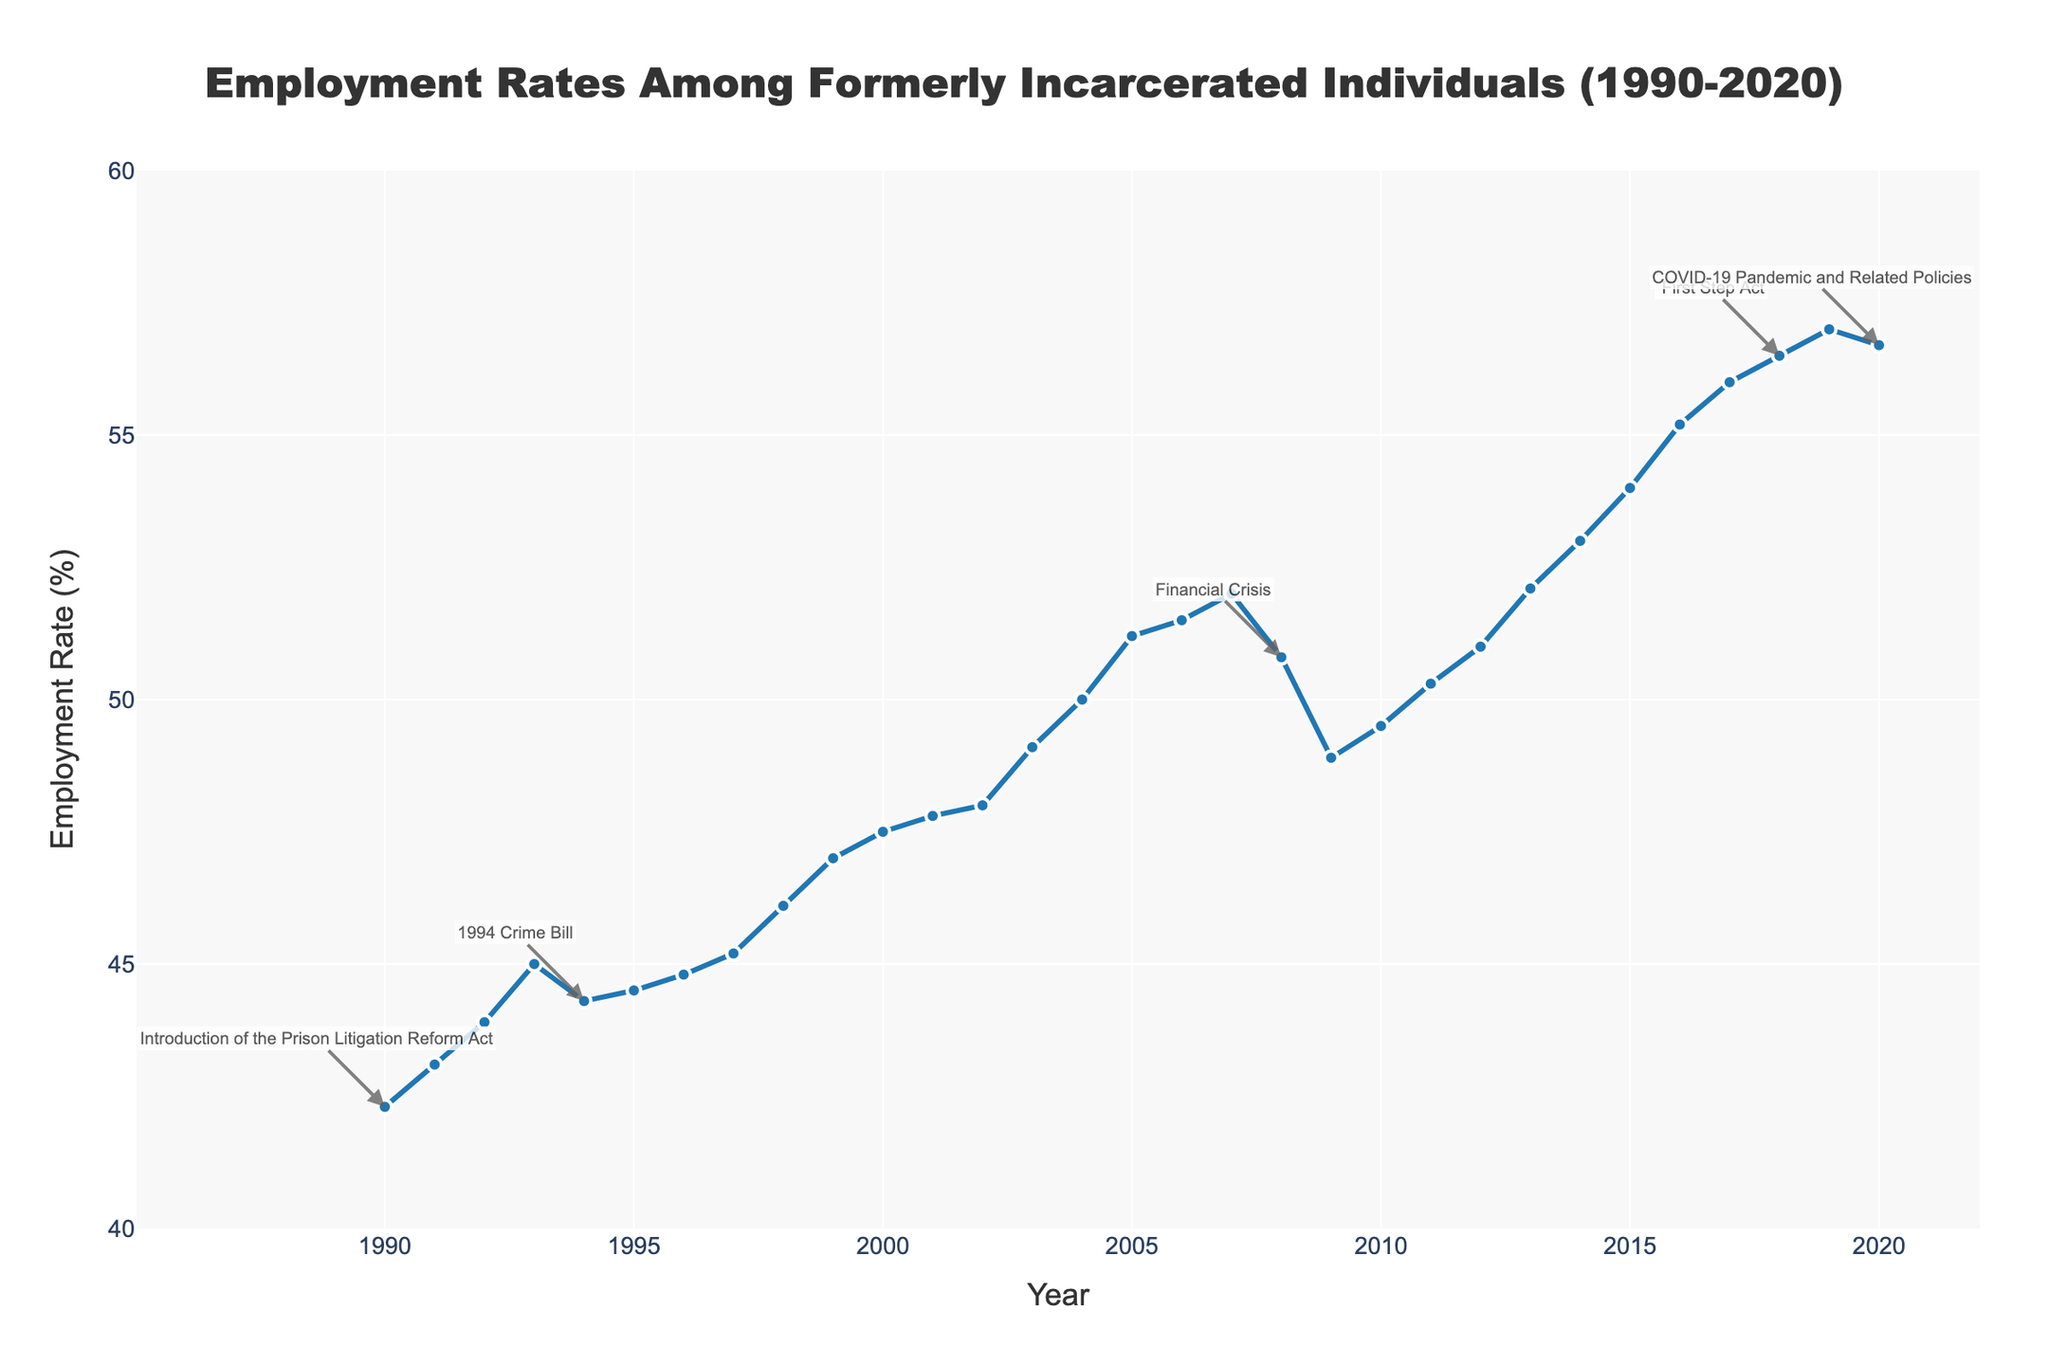What is the title of the plot? The title is centered at the top of the plot and reads "Employment Rates Among Formerly Incarcerated Individuals (1990-2020)."
Answer: Employment Rates Among Formerly Incarcerated Individuals (1990-2020) What does the vertical axis represent? The vertical axis represents the Employment Rate (%), as indicated by the label on the y-axis.
Answer: Employment Rate (%) How does the employment rate change from 1990 to 2020? By observing the plot, the employment rate among formerly incarcerated individuals generally increases from around 42.3% in 1990 to approximately 56.7% in 2020, though there are fluctuations.
Answer: Generally increases with fluctuations Which year shows the lowest employment rate? The plot indicates that the lowest employment rate is around 42.3% in 1990, as it is the first data point on the line at the lowest level.
Answer: 1990 What is the impact of the 2008 Financial Crisis on the employment rate? Around 2008, the employment rate drops from about 52% in 2007 to 50.8% in 2008 and further to 48.9% in 2009, indicating a negative impact on employment rates during the Financial Crisis.
Answer: Negative impact, drops to 48.9% by 2009 How many major policy changes are annotated on the plot? The annotations for major policy changes are visible at four points on the plot, corresponding to the "Introduction of the Prison Litigation Reform Act," "1994 Crime Bill," "Financial Crisis," "First Step Act," and "COVID-19 Pandemic and Related Policies."
Answer: Five In which years did the employment rate see notable increases? Notable increases in employment rate can be observed in the following years: from 1992 to 1993, from 1997 to 1998, from 2003 to 2004, and from 2017 to 2018.
Answer: 1992-1993, 1997-1998, 2003-2004, 2017-2018 What was the employment rate in the year when the First Step Act was introduced? The employment rate in 2018, the year when the First Step Act was introduced, is approximately 56.5%, according to the plot.
Answer: 56.5% Compare the employment rates before and after the 1994 Crime Bill. Before the 1994 Crime Bill, the employment rate was 45.0% in 1993. After the Bill, in 1995, the rate is 44.5%, showing a slight decrease initially.
Answer: Slightly decreased (45.0% to 44.5%) How does the highest employment rate compare to the lowest? The highest employment rate is around 57.0% in 2019, and the lowest is about 42.3% in 1990. The increase from lowest to highest is 57.0% - 42.3% = 14.7 percentage points.
Answer: 14.7 percentage points higher 